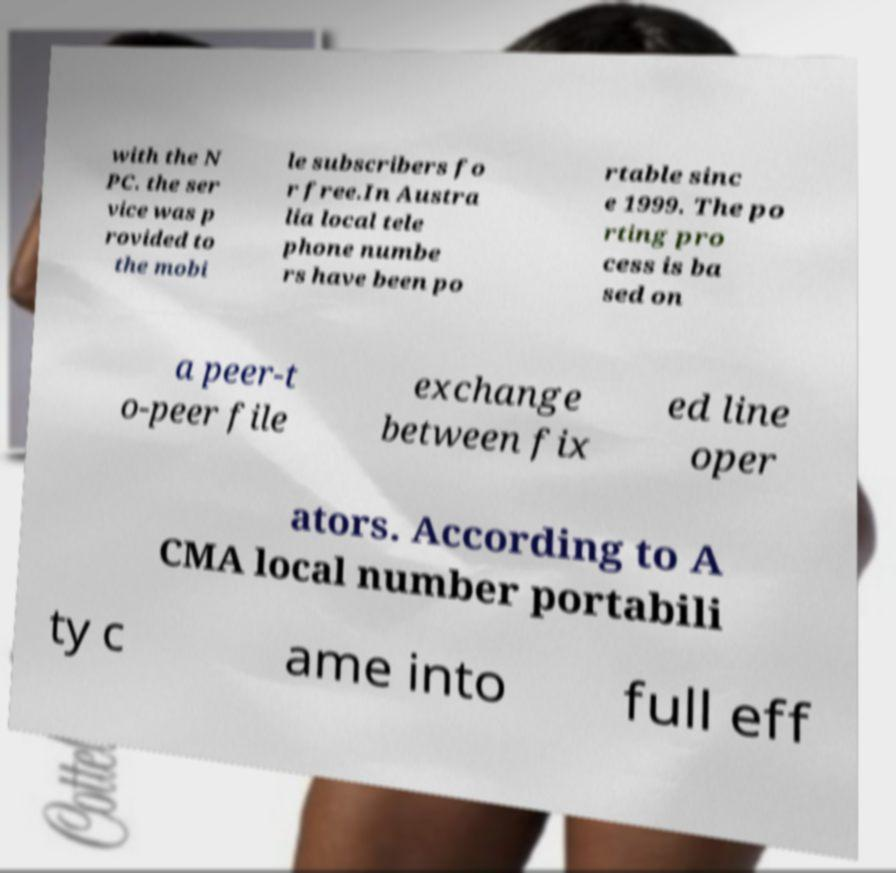Could you assist in decoding the text presented in this image and type it out clearly? with the N PC. the ser vice was p rovided to the mobi le subscribers fo r free.In Austra lia local tele phone numbe rs have been po rtable sinc e 1999. The po rting pro cess is ba sed on a peer-t o-peer file exchange between fix ed line oper ators. According to A CMA local number portabili ty c ame into full eff 